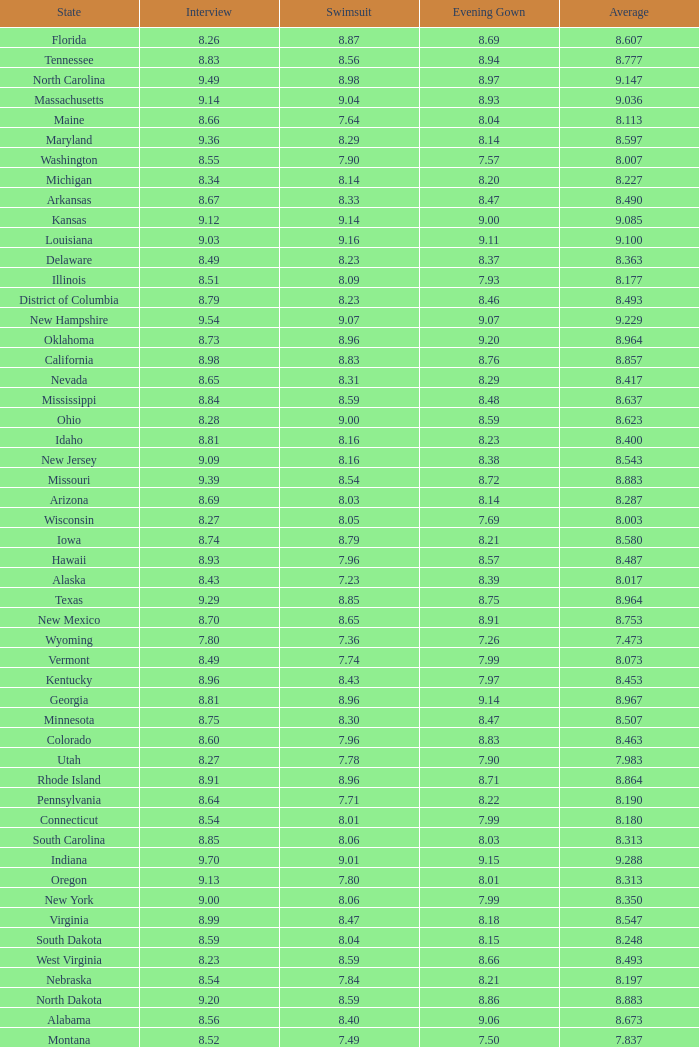Name the total number of swimsuits for evening gowns less than 8.21 and average of 8.453 with interview less than 9.09 1.0. 